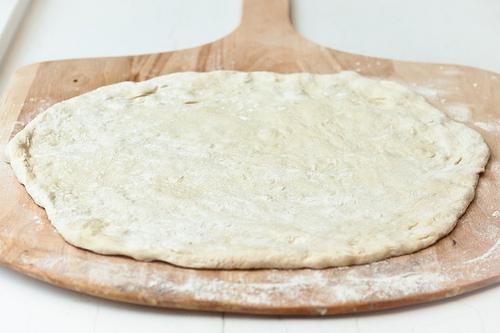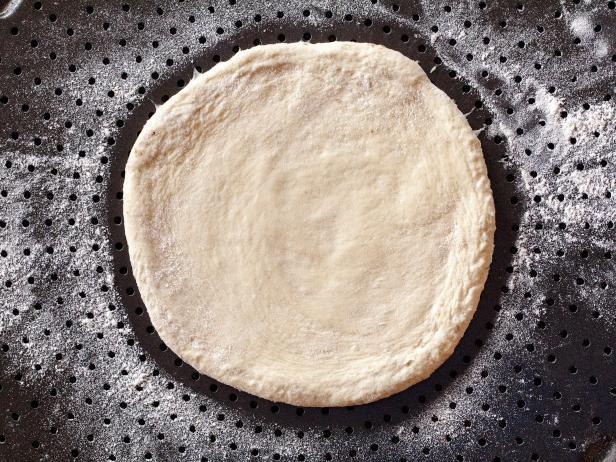The first image is the image on the left, the second image is the image on the right. Assess this claim about the two images: "The dough has been flattened into a pizza crust shape in only one of the images.". Correct or not? Answer yes or no. No. The first image is the image on the left, the second image is the image on the right. Assess this claim about the two images: "In one image a ball of dough is resting on a flour-dusted surface, while a second image shows dough flattened into a round disk.". Correct or not? Answer yes or no. No. 